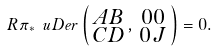Convert formula to latex. <formula><loc_0><loc_0><loc_500><loc_500>R \pi _ { \ast } \ u D e r \left ( \begin{smallmatrix} A B \\ C D \end{smallmatrix} , \begin{smallmatrix} 0 0 \\ 0 J \end{smallmatrix} \right ) = 0 .</formula> 